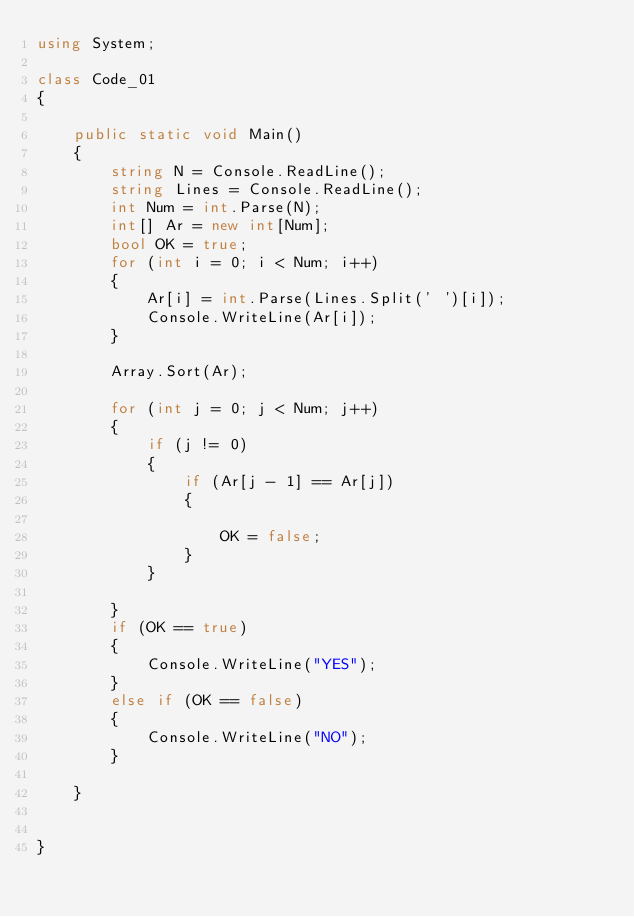<code> <loc_0><loc_0><loc_500><loc_500><_C#_>using System;

class Code_01
{

    public static void Main()
    {
        string N = Console.ReadLine();
        string Lines = Console.ReadLine();
        int Num = int.Parse(N);
        int[] Ar = new int[Num];
        bool OK = true;
        for (int i = 0; i < Num; i++)
        {
            Ar[i] = int.Parse(Lines.Split(' ')[i]);
            Console.WriteLine(Ar[i]);
        }
  
        Array.Sort(Ar);
   
        for (int j = 0; j < Num; j++)
        {
            if (j != 0)
            {
                if (Ar[j - 1] == Ar[j])
                {
                  
                    OK = false;
                }
            }

        }
        if (OK == true)
        {
            Console.WriteLine("YES");
        }
        else if (OK == false)
        {
            Console.WriteLine("NO");
        }

    }


}

</code> 